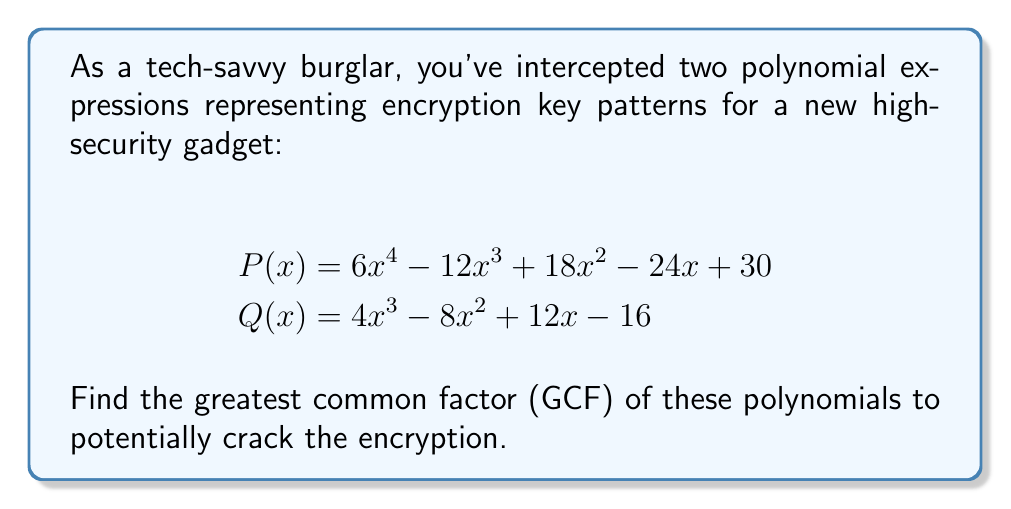Give your solution to this math problem. To find the GCF of these polynomials, we'll follow these steps:

1) First, factor out the GCF of the coefficients for each polynomial:

   $P(x) = 6(x^4 - 2x^3 + 3x^2 - 4x + 5)$
   $Q(x) = 4(x^3 - 2x^2 + 3x - 4)$

2) The GCF of 6 and 4 is 2.

3) Now, we need to find the GCF of the polynomial parts. Let's compare the terms:

   $x^4 - 2x^3 + 3x^2 - 4x + 5$
   $x^3 - 2x^2 + 3x - 4$

4) We can see that there's no common factor among these terms.

5) Therefore, the GCF of the polynomials is just the numeric factor we found in step 2, which is 2.

6) Thus, the GCF of $P(x)$ and $Q(x)$ is 2.
Answer: $2$ 